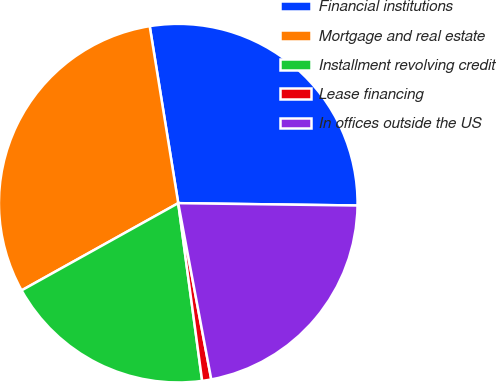Convert chart. <chart><loc_0><loc_0><loc_500><loc_500><pie_chart><fcel>Financial institutions<fcel>Mortgage and real estate<fcel>Installment revolving credit<fcel>Lease financing<fcel>In offices outside the US<nl><fcel>27.75%<fcel>30.54%<fcel>19.04%<fcel>0.82%<fcel>21.84%<nl></chart> 